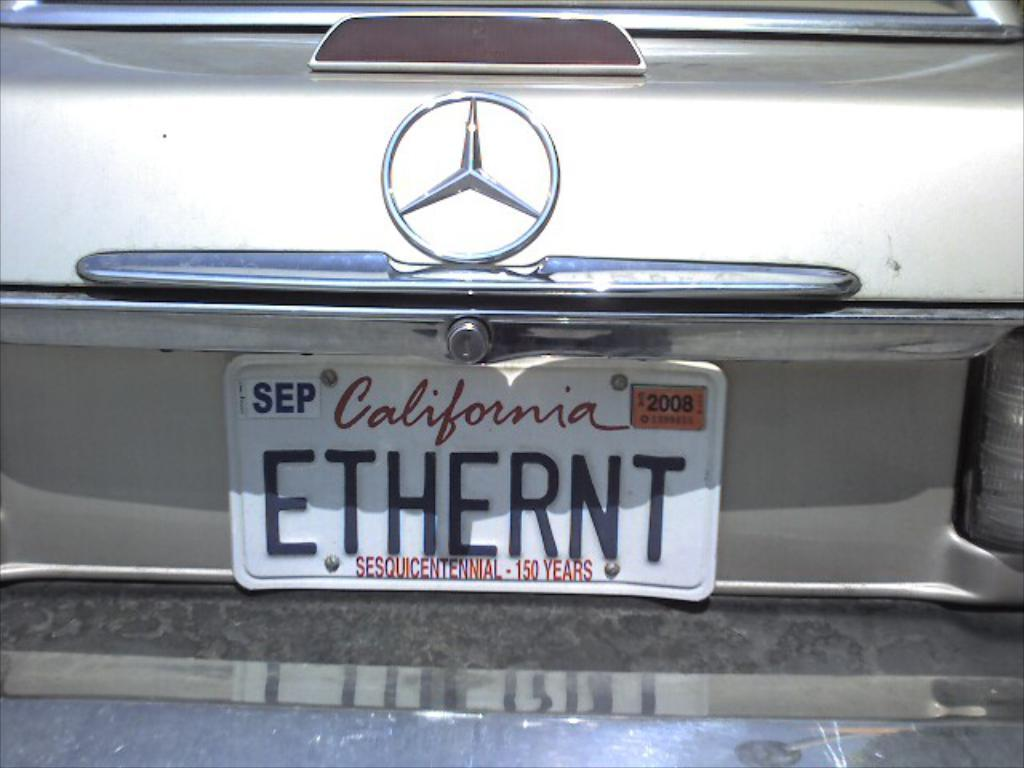<image>
Relay a brief, clear account of the picture shown. White California license plate which says ETHERNT on it. 